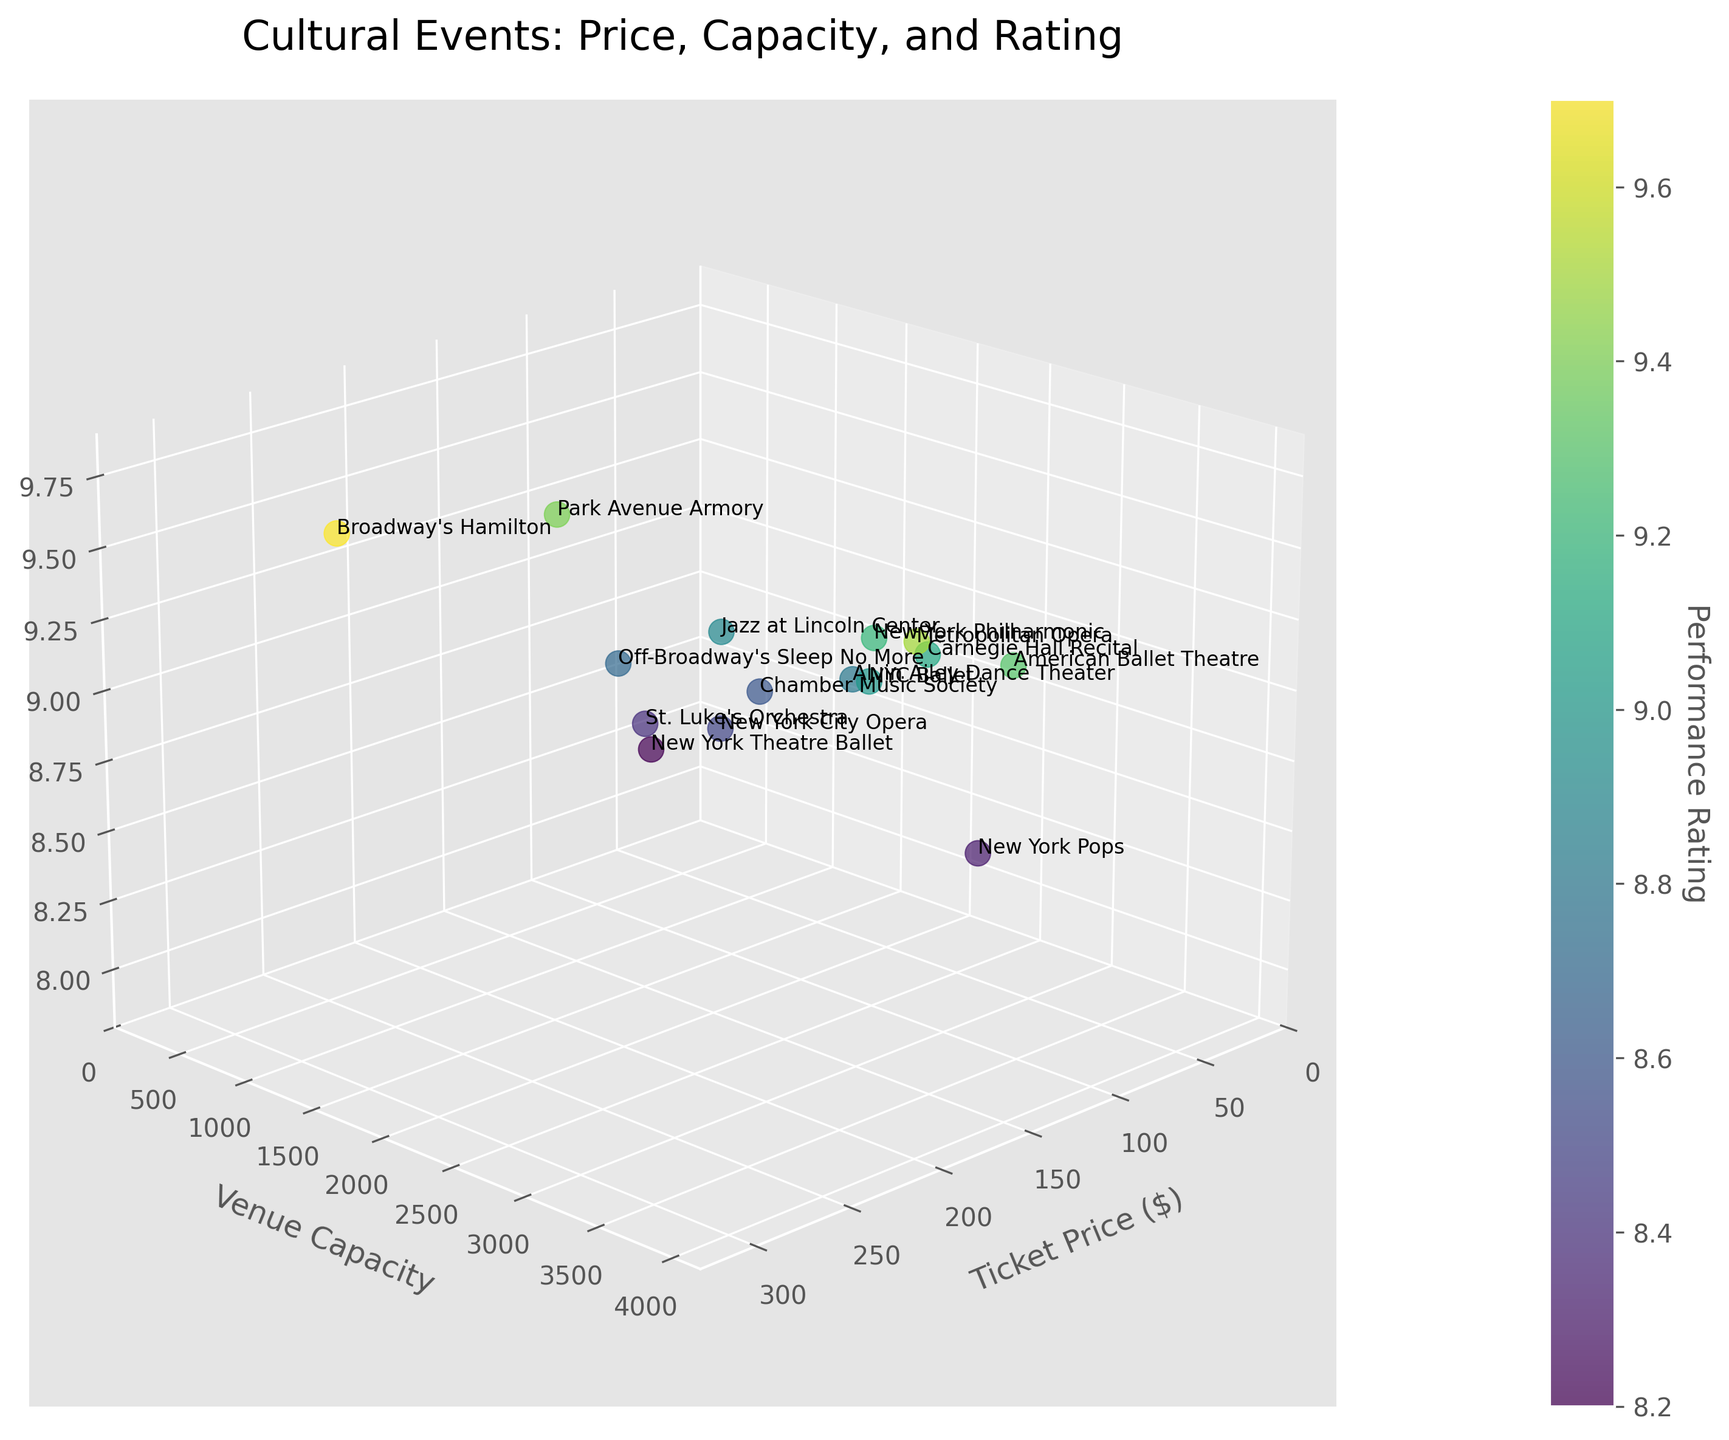What is the title of the plot? The title of the plot is written at the top. It says "Cultural Events: Price, Capacity, and Rating".
Answer: Cultural Events: Price, Capacity, and Rating What is the performance rating of the event with the highest ticket price? First, identify the event with the highest ticket price by locating the highest x-coordinate value, which is for "Broadway's Hamilton" at $299. Then, look at its z-coordinate, which shows the performance rating.
Answer: 9.7 Which event has the smallest venue capacity? Look for the event at the lowest y-coordinate value which denotes venue capacity. The smallest value belongs to "New York Theatre Ballet" with a capacity of 200.
Answer: New York Theatre Ballet How many events have a ticket price greater than $150? Look at the x-axis for data points where the x-coordinate (ticket price) is greater than 150. These points correspond to "Metropolitan Opera", "Broadway's Hamilton", "American Ballet Theatre", and "Park Avenue Armory". Count these points.
Answer: 4 What is the average performance rating for events with a ticket price less than $100? Identify data points with x-coordinates less than 100. These events are "Jazz at Lincoln Center", "Carnegie Hall Recital", "Off-Broadway's Sleep No More", "Alvin Ailey Dance Theater", "New York City Opera", "Chamber Music Society", "St. Luke's Orchestra", and "New York Pops". Note their z-values (performance ratings): 8.9, 9.1, 8.7, 8.8, 8.5, 8.6, 8.4, 8.3. Calculate the average: (8.9+9.1+8.7+8.8+8.5+8.6+8.4+8.3)/8.
Answer: 8.66 Which event has both a moderate ticket price (between $50 and $100) and a high review rating (between 8.5 and 9.5)? Review the events fitting in the x-coordinate range $50-$100 and z-coordinate range 8.5-9.5. "Carnegie Hall Recital" ($95, 9.1), "Off-Broadway's Sleep No More" ($95, 8.7), "Alvin Ailey Dance Theater" ($65, 8.8), "New York City Opera" ($75, 8.5), and "Chamber Music Society" ($55, 8.6) fit the criteria.
Answer: Carnegie Hall Recital, Off-Broadway's Sleep No More, Alvin Ailey Dance Theater, New York City Opera, Chamber Music Society Which event has the highest performance rating among those with ticket prices less than $100? Examine events where the x-coordinate (ticket price) is less than $100. Identify the highest z-coordinate (performance rating). "Carnegie Hall Recital" ($95, 9.1) has the highest rating in this category.
Answer: Carnegie Hall Recital What is the approximate color of the event with the highest performance rating? Find the point with the highest z-coordinate, which is "Broadway's Hamilton" at 9.7. The color is derived from the viridis colormap; points with the highest ratings would be at the end of the color gradient, typically a bright yellow-green.
Answer: Bright yellow-green What event is closest to the origin (0, 0, 0) in the plot? The origin is at (0,0,0). Measure distances of points from the origin using their coordinates. "New York Theatre Ballet" is closest with coordinates approximately (45, 200, 8.2).
Answer: New York Theatre Ballet 